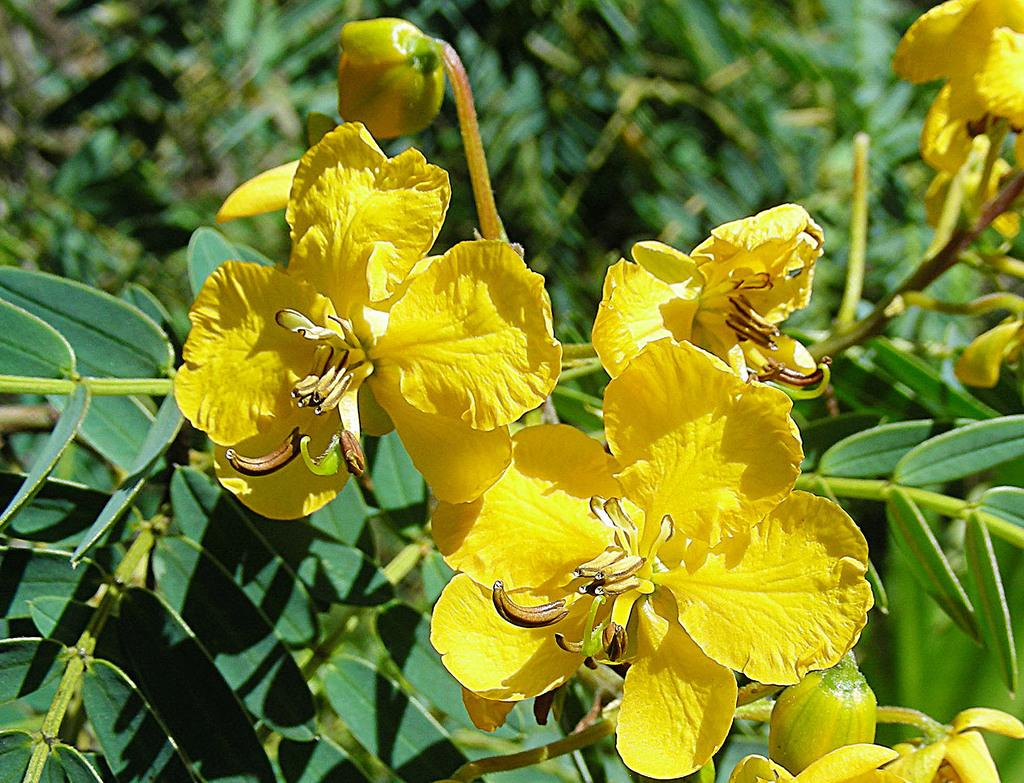What type of flowers can be seen on the plant in the image? There are yellow flowers on a plant in the image. Can you describe the color of the flowers? The flowers are yellow. What is the main subject of the image? The main subject of the image is a plant with yellow flowers. What type of corn is growing in the glass jar in the image? There is no corn or glass jar present in the image; it features a plant with yellow flowers. 